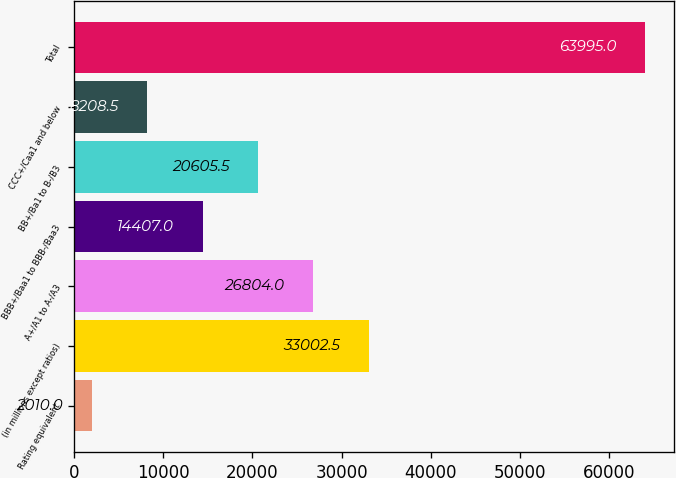<chart> <loc_0><loc_0><loc_500><loc_500><bar_chart><fcel>Rating equivalent<fcel>(in millions except ratios)<fcel>A+/A1 to A-/A3<fcel>BBB+/Baa1 to BBB-/Baa3<fcel>BB+/Ba1 to B-/B3<fcel>CCC+/Caa1 and below<fcel>Total<nl><fcel>2010<fcel>33002.5<fcel>26804<fcel>14407<fcel>20605.5<fcel>8208.5<fcel>63995<nl></chart> 